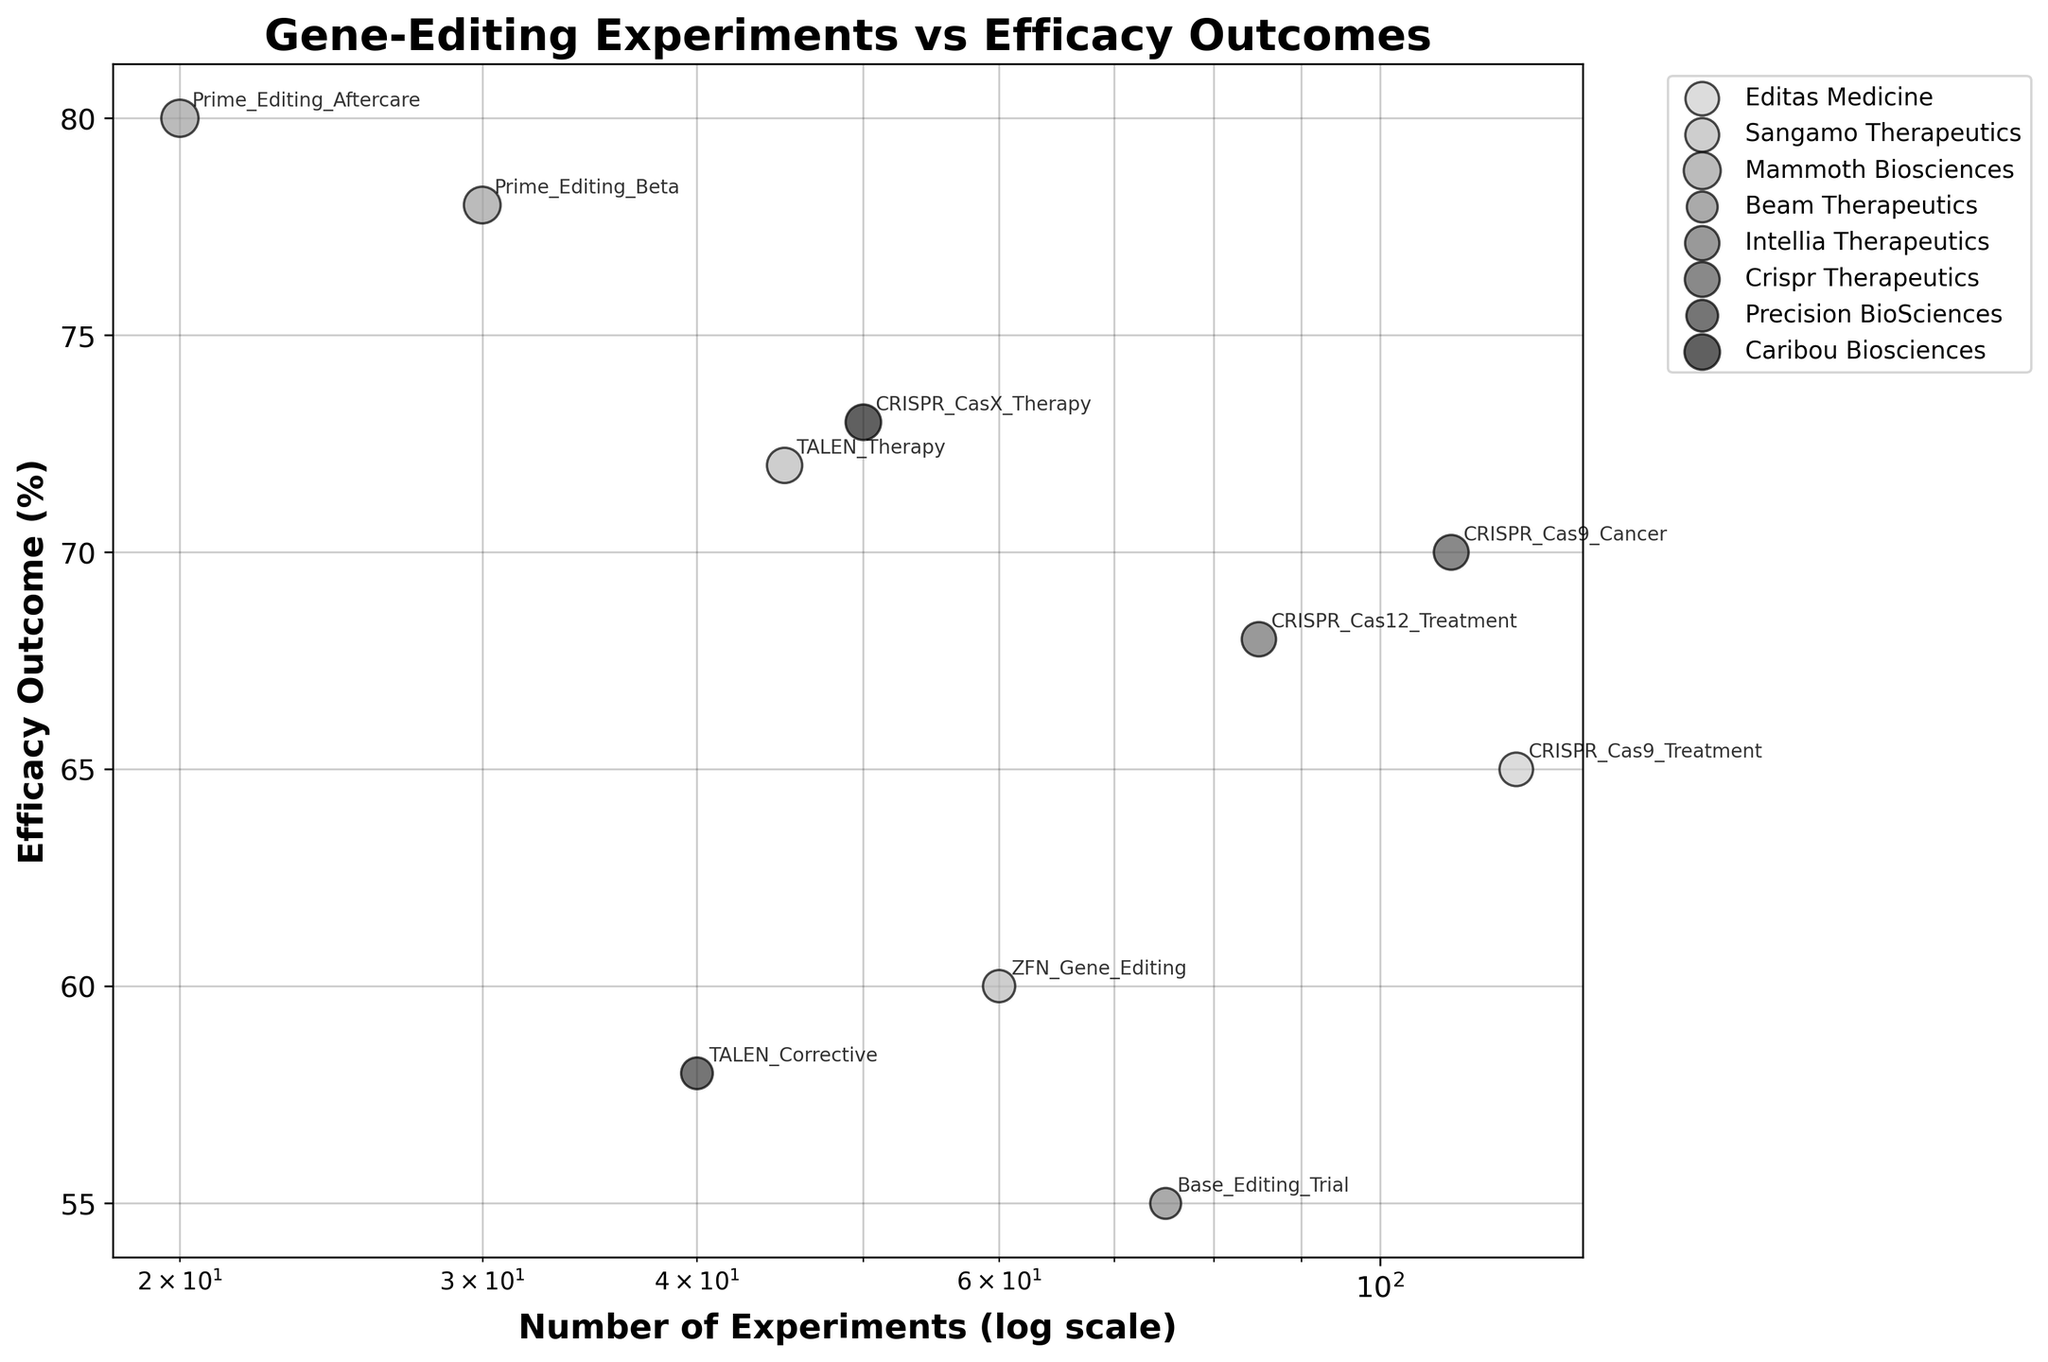What is the title of the scatter plot? The title of the scatter plot is usually found at the top center of the figure. From the provided code, the title is specifically set.
Answer: Gene-Editing Experiments vs Efficacy Outcomes How many companies are represented in the scatter plot? The number of companies can be identified by the different labels in the legend or by counting the unique colors on the plot.
Answer: 6 Which company has the highest efficacy outcome in a single experiment? Look for the highest point on the vertical axis and check the annotation or the legend color to identify the company. The highest point is at 80%.
Answer: Mammoth Biosciences What are the axis labels for this scatter plot? The axis labels are usually placed along the horizontal and vertical axes. They tell you what the axes represent.
Answer: Number of Experiments (log scale), Efficacy Outcome (%) Compare the efficacy outcomes of CRISPR Cas9 Cancer and Base Editing Trial. Which one is higher? Find the points labeled as CRISPR Cas9 Cancer and Base Editing Trial. Look at their positions on the vertical axis (Efficacy Outcome).
Answer: CRISPR Cas9 Cancer Which company has conducted the most experiments, and what is their efficacy outcome? In a log scale scatter plot, find the rightmost point and check its annotation or legend color for the company and its vertical position for the efficacy outcome.
Answer: Editas Medicine (120 experiments, 65% efficacy) What is the average efficacy outcome of the experiments conducted by Sangamo Therapeutics? Locate the points for all experiments by Sangamo Therapeutics (TALEN Therapy and ZFN Gene Editing). Add their efficacy outcomes and divide by the number of experiments. (72% + 60%) / 2 = 66%
Answer: 66% Which experiment had the lowest efficacy outcome, and what was the percentage? Find the lowest point on the vertical axis and read its annotation for the experiment name and vertical position for the percentage.
Answer: Base Editing Trial, 55% Is there any correlation between the number of experiments and efficacy outcomes based on the scatter plot? Observing the scatter plot, one assesses the general trend of the data points. On a log scale, if points form an upward pattern, there's a positive correlation.
Answer: There is no clear correlation 